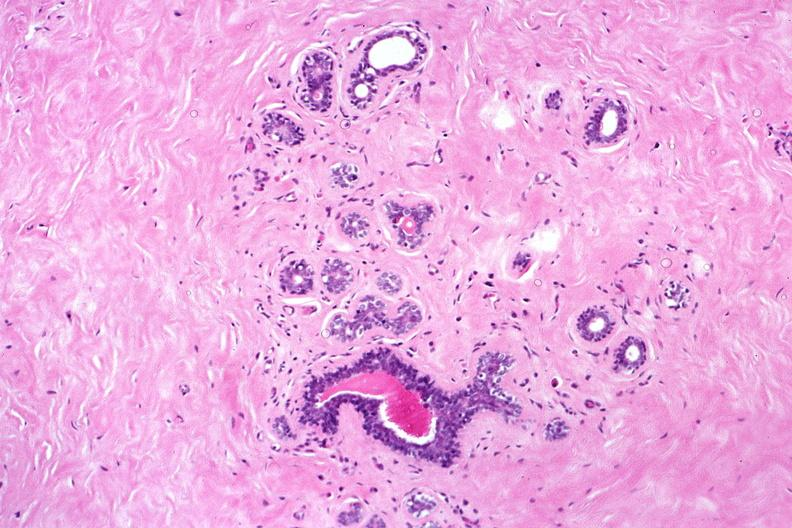s outside adrenal capsule section present?
Answer the question using a single word or phrase. No 